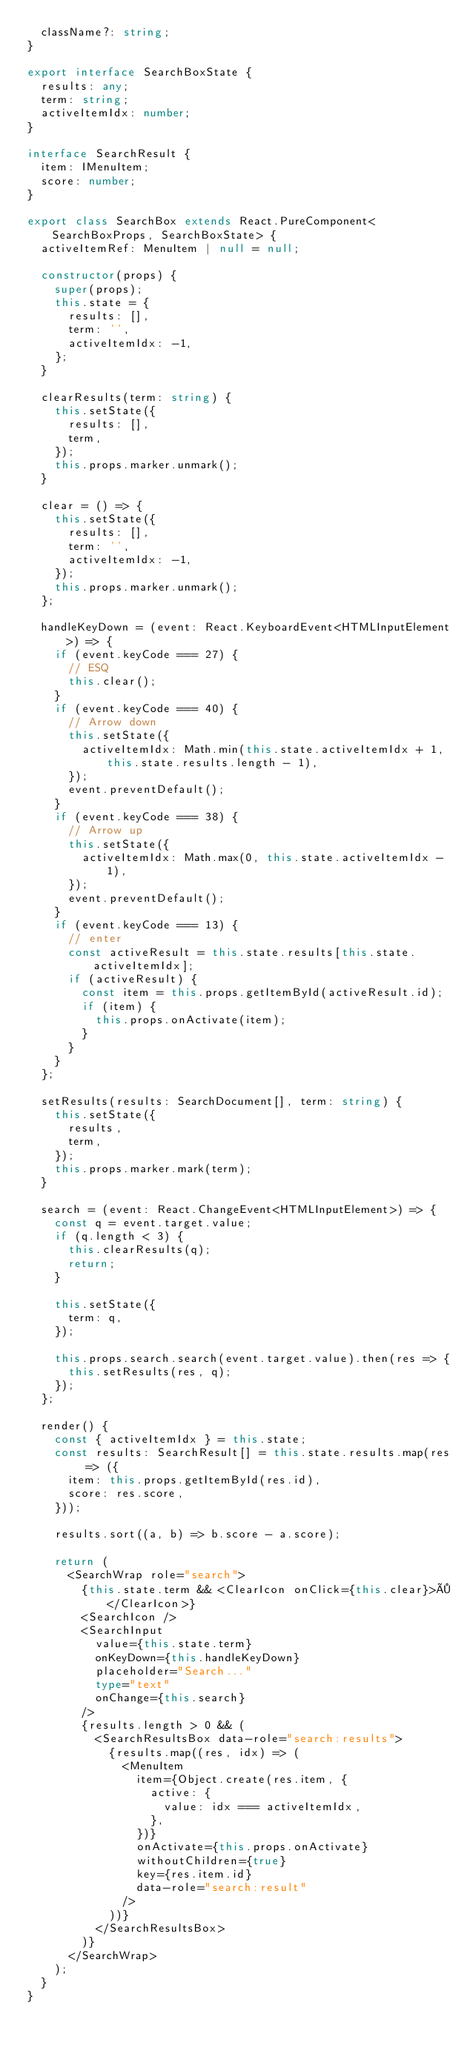Convert code to text. <code><loc_0><loc_0><loc_500><loc_500><_TypeScript_>  className?: string;
}

export interface SearchBoxState {
  results: any;
  term: string;
  activeItemIdx: number;
}

interface SearchResult {
  item: IMenuItem;
  score: number;
}

export class SearchBox extends React.PureComponent<SearchBoxProps, SearchBoxState> {
  activeItemRef: MenuItem | null = null;

  constructor(props) {
    super(props);
    this.state = {
      results: [],
      term: '',
      activeItemIdx: -1,
    };
  }

  clearResults(term: string) {
    this.setState({
      results: [],
      term,
    });
    this.props.marker.unmark();
  }

  clear = () => {
    this.setState({
      results: [],
      term: '',
      activeItemIdx: -1,
    });
    this.props.marker.unmark();
  };

  handleKeyDown = (event: React.KeyboardEvent<HTMLInputElement>) => {
    if (event.keyCode === 27) {
      // ESQ
      this.clear();
    }
    if (event.keyCode === 40) {
      // Arrow down
      this.setState({
        activeItemIdx: Math.min(this.state.activeItemIdx + 1, this.state.results.length - 1),
      });
      event.preventDefault();
    }
    if (event.keyCode === 38) {
      // Arrow up
      this.setState({
        activeItemIdx: Math.max(0, this.state.activeItemIdx - 1),
      });
      event.preventDefault();
    }
    if (event.keyCode === 13) {
      // enter
      const activeResult = this.state.results[this.state.activeItemIdx];
      if (activeResult) {
        const item = this.props.getItemById(activeResult.id);
        if (item) {
          this.props.onActivate(item);
        }
      }
    }
  };

  setResults(results: SearchDocument[], term: string) {
    this.setState({
      results,
      term,
    });
    this.props.marker.mark(term);
  }

  search = (event: React.ChangeEvent<HTMLInputElement>) => {
    const q = event.target.value;
    if (q.length < 3) {
      this.clearResults(q);
      return;
    }

    this.setState({
      term: q,
    });

    this.props.search.search(event.target.value).then(res => {
      this.setResults(res, q);
    });
  };

  render() {
    const { activeItemIdx } = this.state;
    const results: SearchResult[] = this.state.results.map(res => ({
      item: this.props.getItemById(res.id),
      score: res.score,
    }));

    results.sort((a, b) => b.score - a.score);

    return (
      <SearchWrap role="search">
        {this.state.term && <ClearIcon onClick={this.clear}>×</ClearIcon>}
        <SearchIcon />
        <SearchInput
          value={this.state.term}
          onKeyDown={this.handleKeyDown}
          placeholder="Search..."
          type="text"
          onChange={this.search}
        />
        {results.length > 0 && (
          <SearchResultsBox data-role="search:results">
            {results.map((res, idx) => (
              <MenuItem
                item={Object.create(res.item, {
                  active: {
                    value: idx === activeItemIdx,
                  },
                })}
                onActivate={this.props.onActivate}
                withoutChildren={true}
                key={res.item.id}
                data-role="search:result"
              />
            ))}
          </SearchResultsBox>
        )}
      </SearchWrap>
    );
  }
}
</code> 